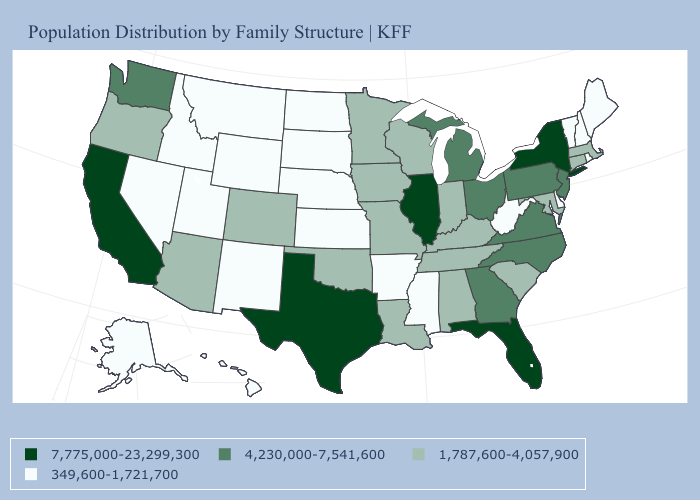How many symbols are there in the legend?
Answer briefly. 4. Which states have the lowest value in the South?
Be succinct. Arkansas, Delaware, Mississippi, West Virginia. Name the states that have a value in the range 1,787,600-4,057,900?
Answer briefly. Alabama, Arizona, Colorado, Connecticut, Indiana, Iowa, Kentucky, Louisiana, Maryland, Massachusetts, Minnesota, Missouri, Oklahoma, Oregon, South Carolina, Tennessee, Wisconsin. Name the states that have a value in the range 7,775,000-23,299,300?
Short answer required. California, Florida, Illinois, New York, Texas. Does the first symbol in the legend represent the smallest category?
Be succinct. No. Does the map have missing data?
Write a very short answer. No. What is the lowest value in the USA?
Keep it brief. 349,600-1,721,700. Name the states that have a value in the range 1,787,600-4,057,900?
Keep it brief. Alabama, Arizona, Colorado, Connecticut, Indiana, Iowa, Kentucky, Louisiana, Maryland, Massachusetts, Minnesota, Missouri, Oklahoma, Oregon, South Carolina, Tennessee, Wisconsin. Does Vermont have a lower value than New Jersey?
Be succinct. Yes. Does New York have the highest value in the Northeast?
Quick response, please. Yes. Which states have the lowest value in the USA?
Short answer required. Alaska, Arkansas, Delaware, Hawaii, Idaho, Kansas, Maine, Mississippi, Montana, Nebraska, Nevada, New Hampshire, New Mexico, North Dakota, Rhode Island, South Dakota, Utah, Vermont, West Virginia, Wyoming. What is the highest value in the Northeast ?
Quick response, please. 7,775,000-23,299,300. Which states have the lowest value in the West?
Short answer required. Alaska, Hawaii, Idaho, Montana, Nevada, New Mexico, Utah, Wyoming. What is the lowest value in states that border South Dakota?
Keep it brief. 349,600-1,721,700. 